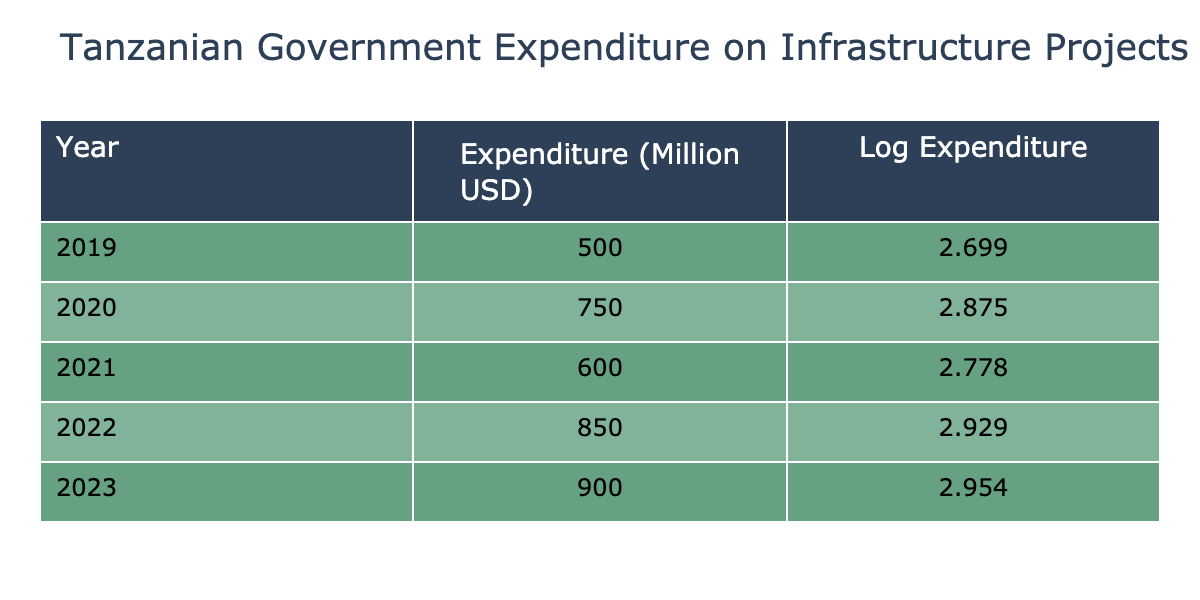What was the government expenditure on infrastructure projects in 2020? The table shows that the government expenditure on infrastructure projects in 2020 was 750 million USD.
Answer: 750 million USD What was the minimum government expenditure during the five-year period? By examining the data, the minimum expenditure is 500 million USD, which occurred in 2019.
Answer: 500 million USD What was the total government expenditure on infrastructure projects from 2019 to 2023? Calculating the total involves summing the expenditures: 500 + 750 + 600 + 850 + 900 = 3600 million USD.
Answer: 3600 million USD Was there an increase in government expenditure from 2021 to 2022? From the table, the expenditure in 2021 was 600 million USD and in 2022 it was 850 million USD. Since 850 > 600, there was indeed an increase.
Answer: Yes What is the average government expenditure over the five years? First, calculate the total expenditure (3600 million USD) and divide it by the number of years (5): 3600 / 5 = 720 million USD.
Answer: 720 million USD Which year had the highest government expenditure on infrastructure projects? Looking at the data, 2023 had the highest expenditure with 900 million USD.
Answer: 2023 Is the government expenditure on infrastructure projects increasing or decreasing over the five years? The expenditures show an overall increasing trend when examining the data between each successive year. 2019 to 2020 increased, 2020 to 2021 decreased, but from 2021 to 2023 they increased again. In total, the trend is upward.
Answer: Increasing overall What was the difference in government expenditure between 2022 and 2019? Subtract the 2019 expenditure (500 million USD) from the 2022 expenditure (850 million USD): 850 - 500 = 350 million USD.
Answer: 350 million USD 